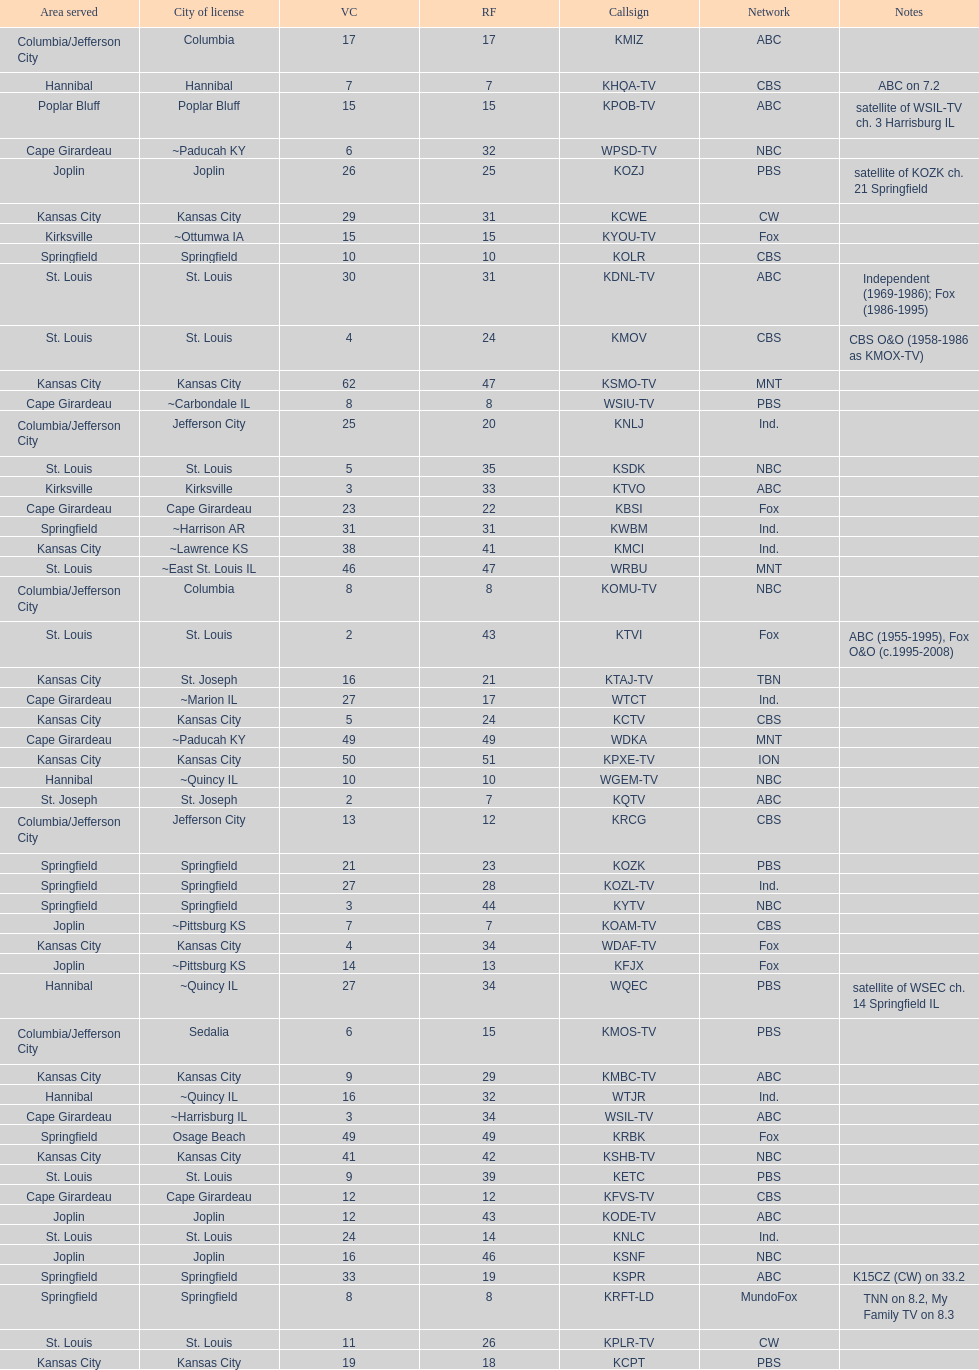I'm looking to parse the entire table for insights. Could you assist me with that? {'header': ['Area served', 'City of license', 'VC', 'RF', 'Callsign', 'Network', 'Notes'], 'rows': [['Columbia/Jefferson City', 'Columbia', '17', '17', 'KMIZ', 'ABC', ''], ['Hannibal', 'Hannibal', '7', '7', 'KHQA-TV', 'CBS', 'ABC on 7.2'], ['Poplar Bluff', 'Poplar Bluff', '15', '15', 'KPOB-TV', 'ABC', 'satellite of WSIL-TV ch. 3 Harrisburg IL'], ['Cape Girardeau', '~Paducah KY', '6', '32', 'WPSD-TV', 'NBC', ''], ['Joplin', 'Joplin', '26', '25', 'KOZJ', 'PBS', 'satellite of KOZK ch. 21 Springfield'], ['Kansas City', 'Kansas City', '29', '31', 'KCWE', 'CW', ''], ['Kirksville', '~Ottumwa IA', '15', '15', 'KYOU-TV', 'Fox', ''], ['Springfield', 'Springfield', '10', '10', 'KOLR', 'CBS', ''], ['St. Louis', 'St. Louis', '30', '31', 'KDNL-TV', 'ABC', 'Independent (1969-1986); Fox (1986-1995)'], ['St. Louis', 'St. Louis', '4', '24', 'KMOV', 'CBS', 'CBS O&O (1958-1986 as KMOX-TV)'], ['Kansas City', 'Kansas City', '62', '47', 'KSMO-TV', 'MNT', ''], ['Cape Girardeau', '~Carbondale IL', '8', '8', 'WSIU-TV', 'PBS', ''], ['Columbia/Jefferson City', 'Jefferson City', '25', '20', 'KNLJ', 'Ind.', ''], ['St. Louis', 'St. Louis', '5', '35', 'KSDK', 'NBC', ''], ['Kirksville', 'Kirksville', '3', '33', 'KTVO', 'ABC', ''], ['Cape Girardeau', 'Cape Girardeau', '23', '22', 'KBSI', 'Fox', ''], ['Springfield', '~Harrison AR', '31', '31', 'KWBM', 'Ind.', ''], ['Kansas City', '~Lawrence KS', '38', '41', 'KMCI', 'Ind.', ''], ['St. Louis', '~East St. Louis IL', '46', '47', 'WRBU', 'MNT', ''], ['Columbia/Jefferson City', 'Columbia', '8', '8', 'KOMU-TV', 'NBC', ''], ['St. Louis', 'St. Louis', '2', '43', 'KTVI', 'Fox', 'ABC (1955-1995), Fox O&O (c.1995-2008)'], ['Kansas City', 'St. Joseph', '16', '21', 'KTAJ-TV', 'TBN', ''], ['Cape Girardeau', '~Marion IL', '27', '17', 'WTCT', 'Ind.', ''], ['Kansas City', 'Kansas City', '5', '24', 'KCTV', 'CBS', ''], ['Cape Girardeau', '~Paducah KY', '49', '49', 'WDKA', 'MNT', ''], ['Kansas City', 'Kansas City', '50', '51', 'KPXE-TV', 'ION', ''], ['Hannibal', '~Quincy IL', '10', '10', 'WGEM-TV', 'NBC', ''], ['St. Joseph', 'St. Joseph', '2', '7', 'KQTV', 'ABC', ''], ['Columbia/Jefferson City', 'Jefferson City', '13', '12', 'KRCG', 'CBS', ''], ['Springfield', 'Springfield', '21', '23', 'KOZK', 'PBS', ''], ['Springfield', 'Springfield', '27', '28', 'KOZL-TV', 'Ind.', ''], ['Springfield', 'Springfield', '3', '44', 'KYTV', 'NBC', ''], ['Joplin', '~Pittsburg KS', '7', '7', 'KOAM-TV', 'CBS', ''], ['Kansas City', 'Kansas City', '4', '34', 'WDAF-TV', 'Fox', ''], ['Joplin', '~Pittsburg KS', '14', '13', 'KFJX', 'Fox', ''], ['Hannibal', '~Quincy IL', '27', '34', 'WQEC', 'PBS', 'satellite of WSEC ch. 14 Springfield IL'], ['Columbia/Jefferson City', 'Sedalia', '6', '15', 'KMOS-TV', 'PBS', ''], ['Kansas City', 'Kansas City', '9', '29', 'KMBC-TV', 'ABC', ''], ['Hannibal', '~Quincy IL', '16', '32', 'WTJR', 'Ind.', ''], ['Cape Girardeau', '~Harrisburg IL', '3', '34', 'WSIL-TV', 'ABC', ''], ['Springfield', 'Osage Beach', '49', '49', 'KRBK', 'Fox', ''], ['Kansas City', 'Kansas City', '41', '42', 'KSHB-TV', 'NBC', ''], ['St. Louis', 'St. Louis', '9', '39', 'KETC', 'PBS', ''], ['Cape Girardeau', 'Cape Girardeau', '12', '12', 'KFVS-TV', 'CBS', ''], ['Joplin', 'Joplin', '12', '43', 'KODE-TV', 'ABC', ''], ['St. Louis', 'St. Louis', '24', '14', 'KNLC', 'Ind.', ''], ['Joplin', 'Joplin', '16', '46', 'KSNF', 'NBC', ''], ['Springfield', 'Springfield', '33', '19', 'KSPR', 'ABC', 'K15CZ (CW) on 33.2'], ['Springfield', 'Springfield', '8', '8', 'KRFT-LD', 'MundoFox', 'TNN on 8.2, My Family TV on 8.3'], ['St. Louis', 'St. Louis', '11', '26', 'KPLR-TV', 'CW', ''], ['Kansas City', 'Kansas City', '19', '18', 'KCPT', 'PBS', '']]} How many of these missouri tv stations are actually licensed in a city in illinois (il)? 7. 